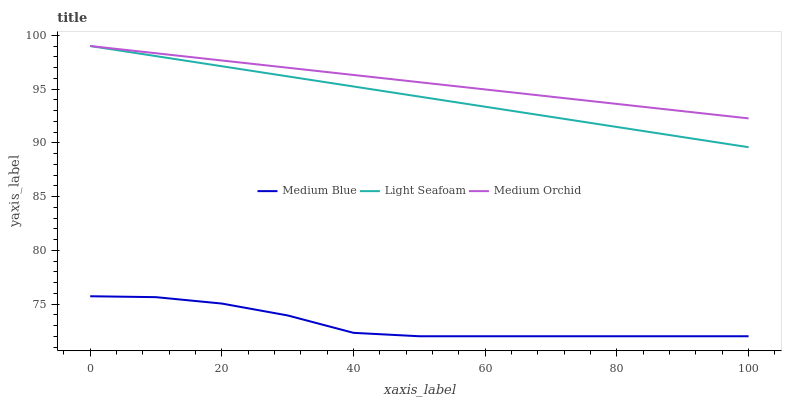Does Medium Blue have the minimum area under the curve?
Answer yes or no. Yes. Does Medium Orchid have the maximum area under the curve?
Answer yes or no. Yes. Does Light Seafoam have the minimum area under the curve?
Answer yes or no. No. Does Light Seafoam have the maximum area under the curve?
Answer yes or no. No. Is Medium Orchid the smoothest?
Answer yes or no. Yes. Is Medium Blue the roughest?
Answer yes or no. Yes. Is Medium Blue the smoothest?
Answer yes or no. No. Is Light Seafoam the roughest?
Answer yes or no. No. Does Medium Blue have the lowest value?
Answer yes or no. Yes. Does Light Seafoam have the lowest value?
Answer yes or no. No. Does Light Seafoam have the highest value?
Answer yes or no. Yes. Does Medium Blue have the highest value?
Answer yes or no. No. Is Medium Blue less than Medium Orchid?
Answer yes or no. Yes. Is Medium Orchid greater than Medium Blue?
Answer yes or no. Yes. Does Light Seafoam intersect Medium Orchid?
Answer yes or no. Yes. Is Light Seafoam less than Medium Orchid?
Answer yes or no. No. Is Light Seafoam greater than Medium Orchid?
Answer yes or no. No. Does Medium Blue intersect Medium Orchid?
Answer yes or no. No. 